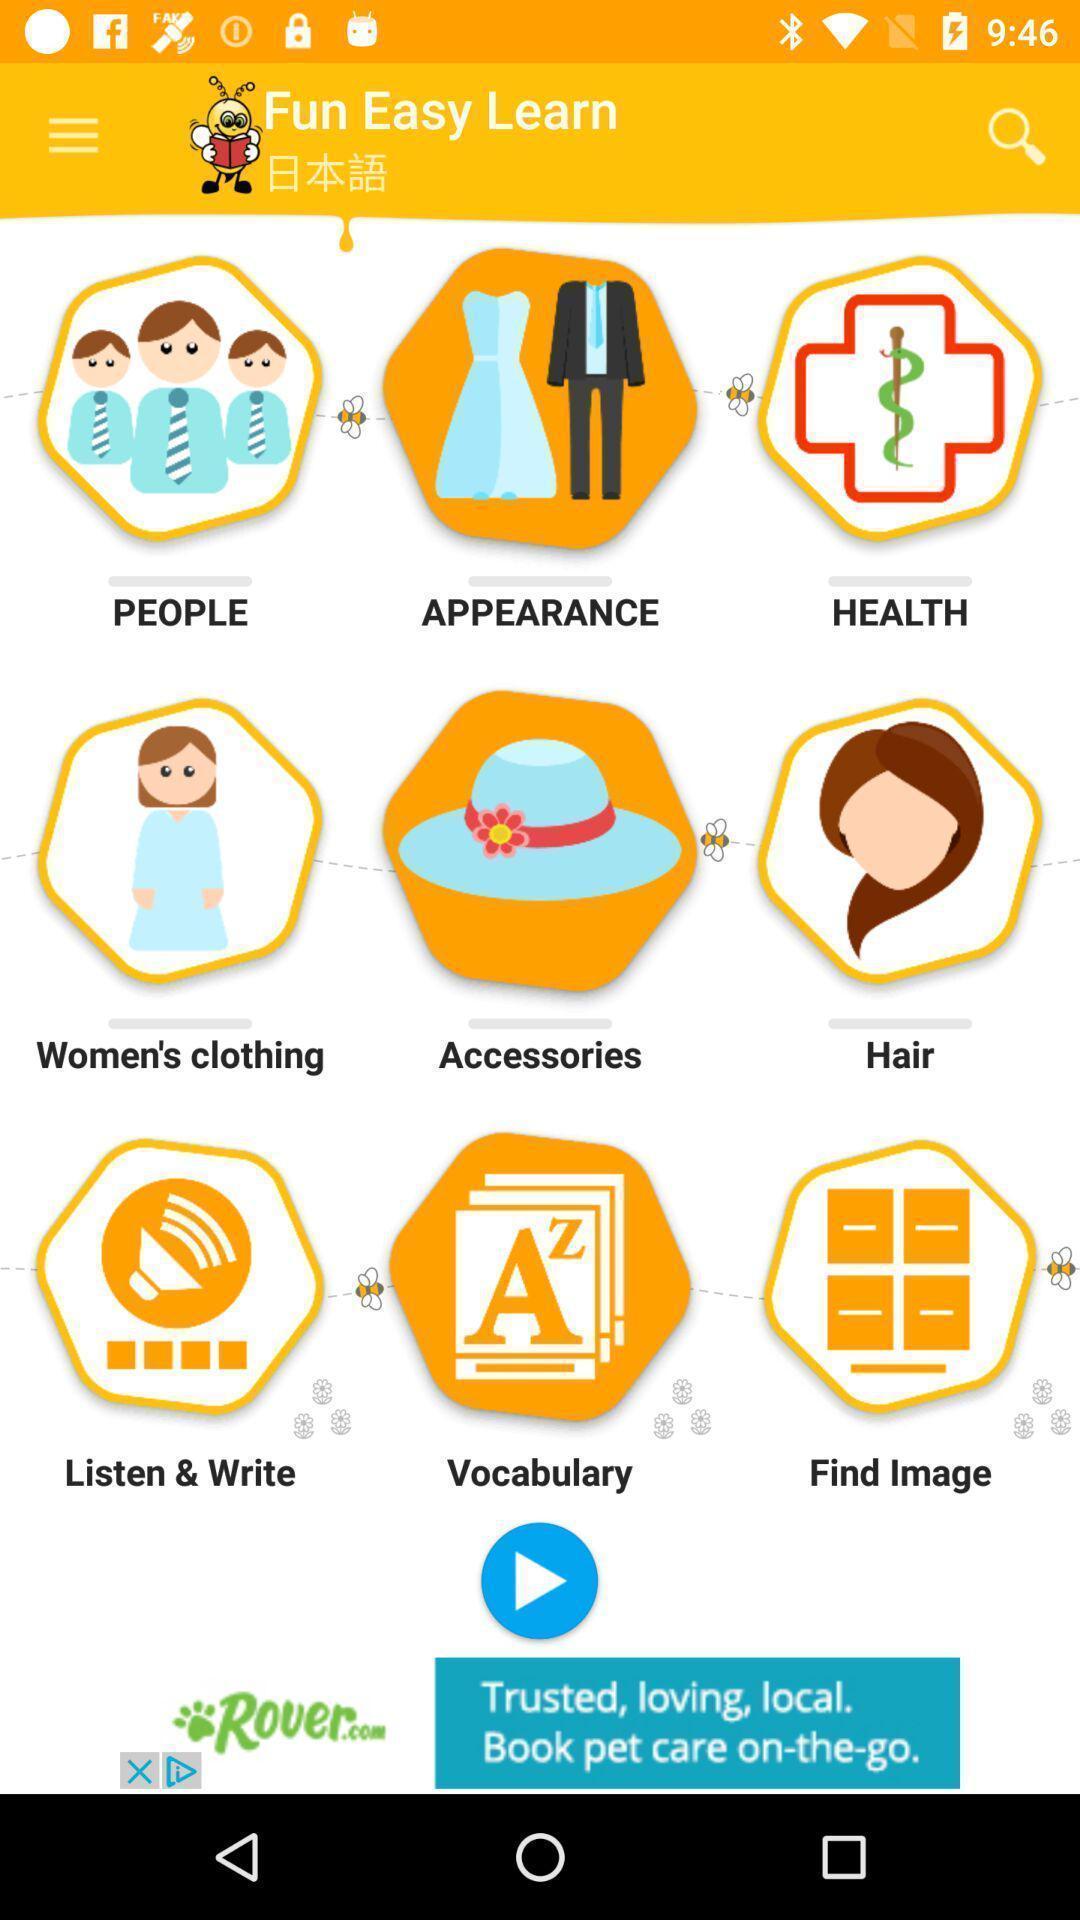Describe this image in words. Screen displaying multiple categories in a language learning application. 